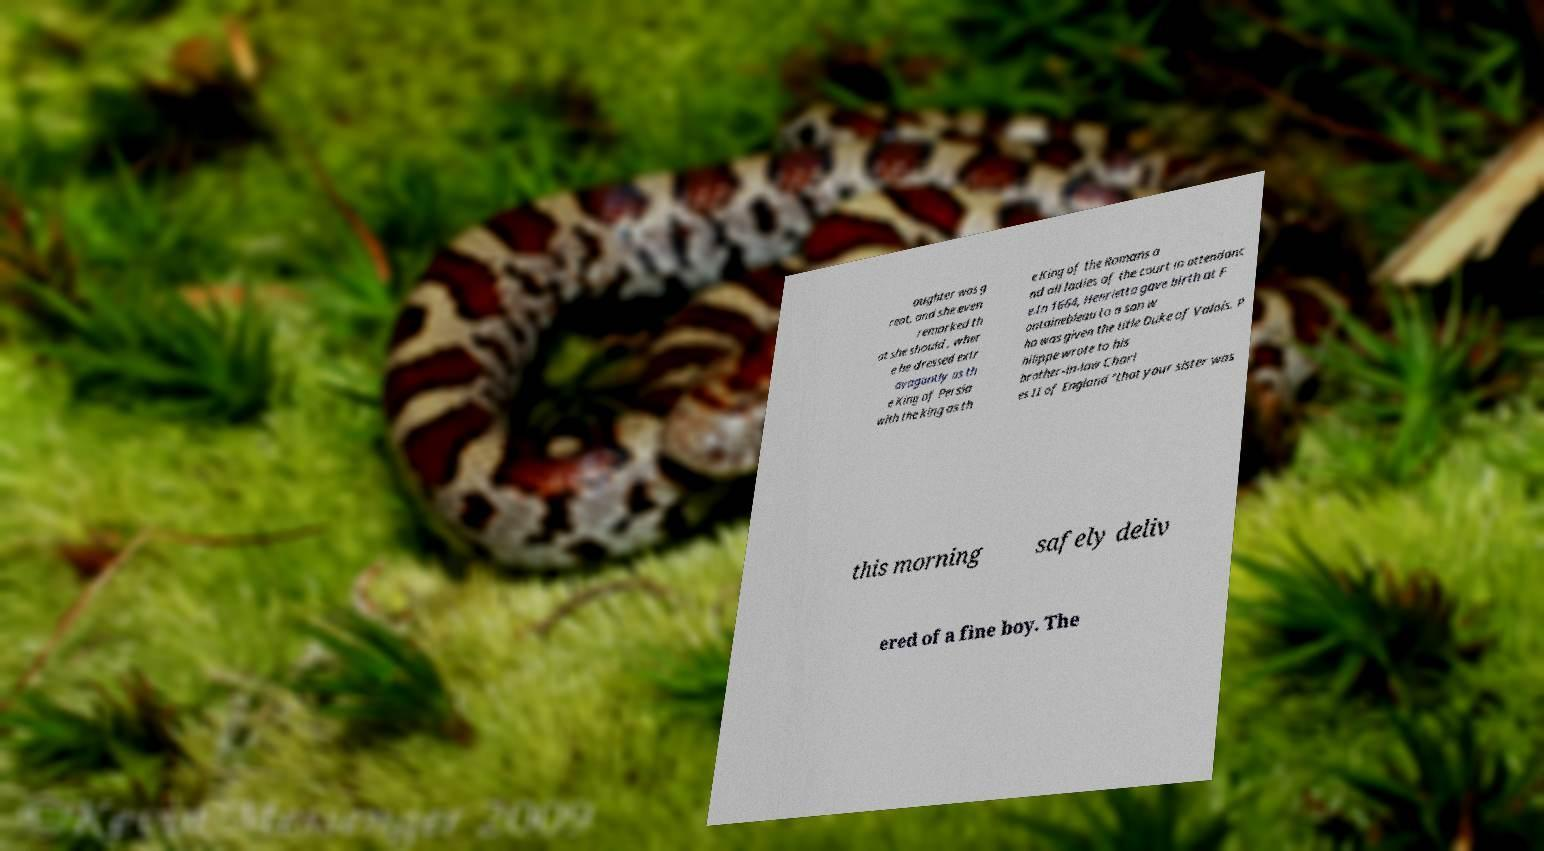Please identify and transcribe the text found in this image. aughter was g reat, and she even remarked th at she should , wher e he dressed extr avagantly as th e King of Persia with the king as th e King of the Romans a nd all ladies of the court in attendanc e.In 1664, Henrietta gave birth at F ontainebleau to a son w ho was given the title Duke of Valois. P hilippe wrote to his brother-in-law Charl es II of England "that your sister was this morning safely deliv ered of a fine boy. The 